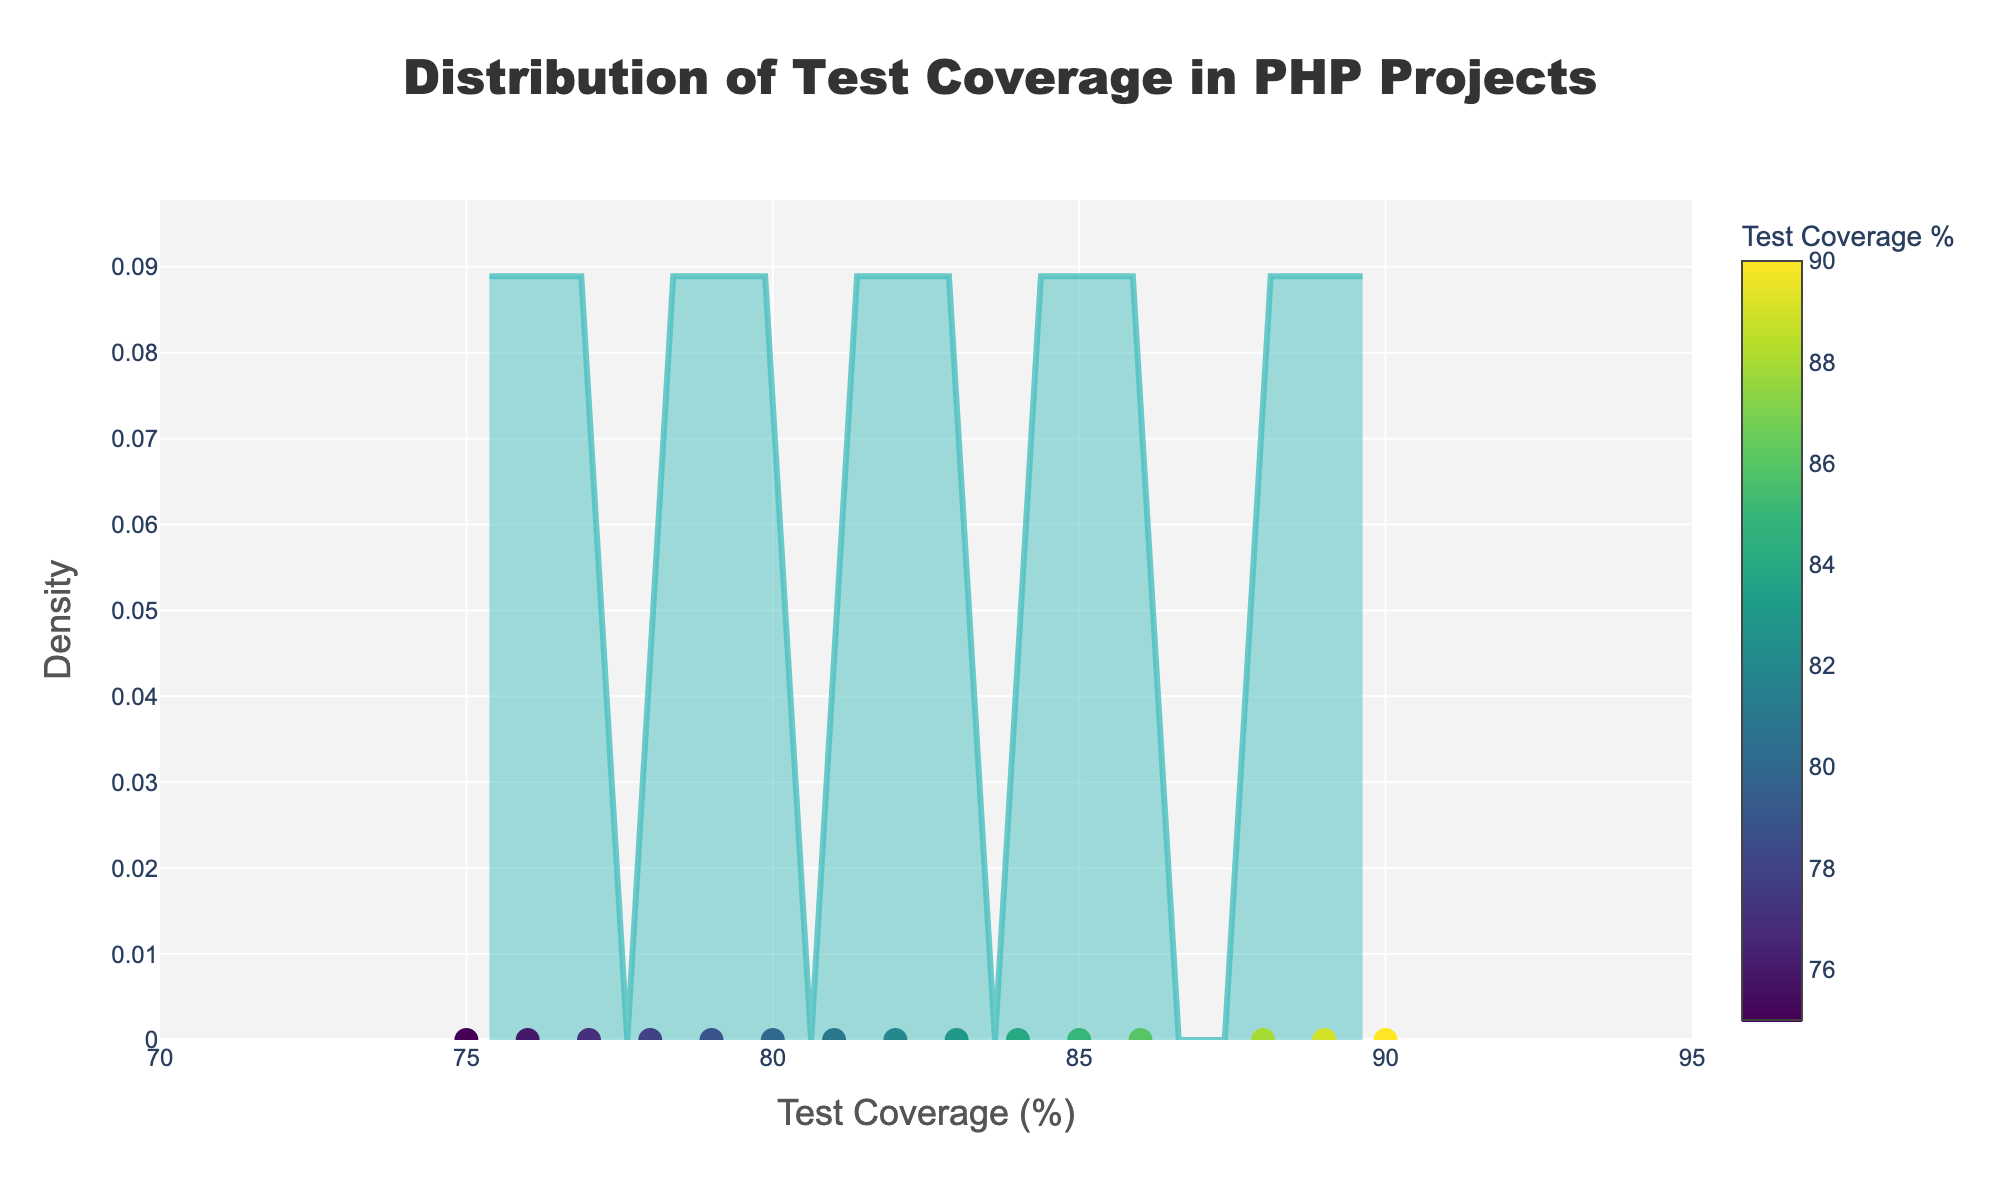What is the title of the plot? The title of the plot is visible at the top and reads "Distribution of Test Coverage in PHP Projects"
Answer: Distribution of Test Coverage in PHP Projects Which project has the highest test coverage percentage? By inspecting the scatter points along the x-axis, the project with the highest test coverage percentage is Symfony with 90%.
Answer: Symfony What is the range of test coverage percentages displayed on the x-axis? The x-axis displays test coverage percentages ranging from 70% to 95%. This can be inferred from the axis ticks and the data points.
Answer: 70-95% How many projects have a test coverage percentage between 80% and 85%? By counting scatter points within the 80% to 85% range on the x-axis, we see the projects: Yii, Phalcon, Kohana, PHPixie, Slim and Aura. This totals to 6 points.
Answer: 6 Which project appears closest to the peak of the density curve? The density curve's peak is around a test coverage of 85%. The project closest to this peak is Laravel with a test coverage of 85%.
Answer: Laravel What is the color scheme used for the markers? The scatter points are colored using the 'Viridis' colorscale, and we can see a gradient of colors ranging from dark blue to yellow.
Answer: Viridis Which project has the lowest test coverage percentage? The project with the lowest test coverage percentage is visible at the far left of the x-axis at 75%, which is CakePHP.
Answer: CakePHP Are there more projects with a test coverage above 80% or below 80%? From visual inspection, more scatter points lie to the right of 80% than to the left. Specifically, 10 projects have coverage above 80%, and 5 below 80%.
Answer: Above 80% What is the approximate density value at a test coverage of 78%? Examining the density curve at the test coverage percentage of 78%, the approximate density value is around 0.06.
Answer: 0.06 How many scatter points represent test coverage exactly at 77%? By inspecting scatter points at 77% on the x-axis, we find that only one project, FuelPHP, falls at this specific value.
Answer: 1 